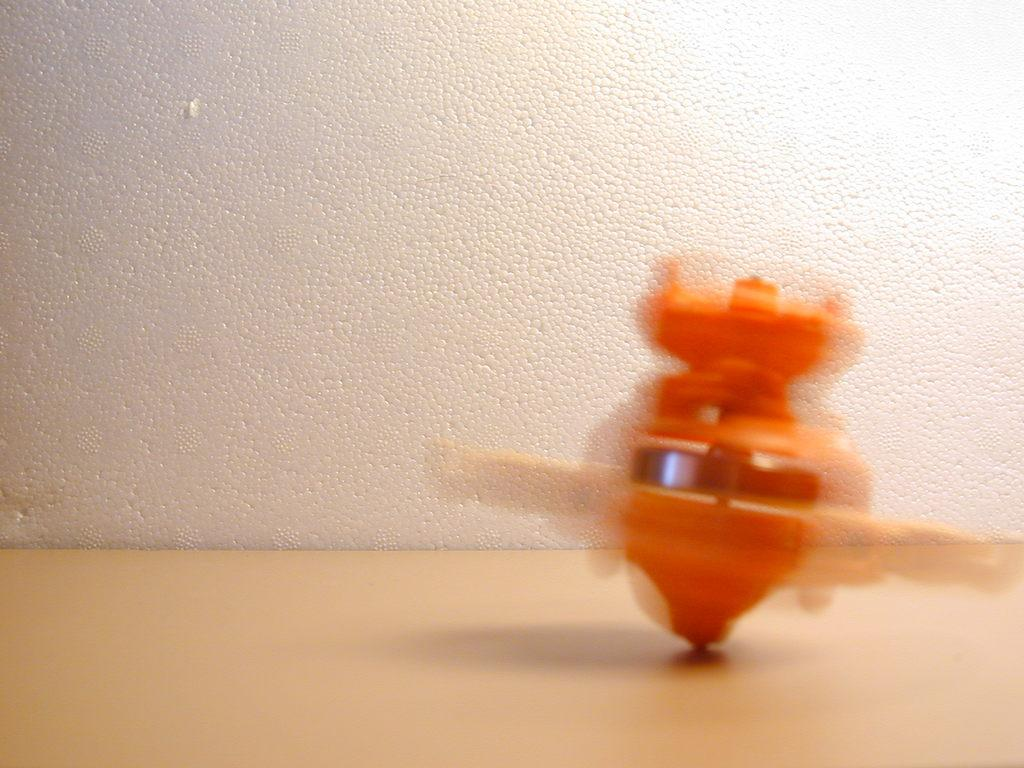What color is the wall in the image? The wall in the image is white. What piece of furniture is present in the image? There is a table in the image. What color is the table? The table is white. What can be seen on top of the table? There is an orange object on the table. What type of smoke can be seen coming from the downtown area in the image? There is no downtown area or smoke present in the image; it only features a white wall, a white table, and an orange object on the table. 